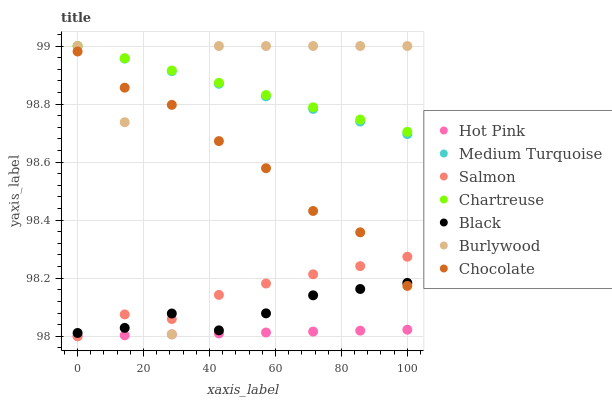Does Hot Pink have the minimum area under the curve?
Answer yes or no. Yes. Does Chartreuse have the maximum area under the curve?
Answer yes or no. Yes. Does Salmon have the minimum area under the curve?
Answer yes or no. No. Does Salmon have the maximum area under the curve?
Answer yes or no. No. Is Medium Turquoise the smoothest?
Answer yes or no. Yes. Is Burlywood the roughest?
Answer yes or no. Yes. Is Hot Pink the smoothest?
Answer yes or no. No. Is Hot Pink the roughest?
Answer yes or no. No. Does Hot Pink have the lowest value?
Answer yes or no. Yes. Does Chocolate have the lowest value?
Answer yes or no. No. Does Medium Turquoise have the highest value?
Answer yes or no. Yes. Does Salmon have the highest value?
Answer yes or no. No. Is Salmon less than Chartreuse?
Answer yes or no. Yes. Is Burlywood greater than Hot Pink?
Answer yes or no. Yes. Does Salmon intersect Black?
Answer yes or no. Yes. Is Salmon less than Black?
Answer yes or no. No. Is Salmon greater than Black?
Answer yes or no. No. Does Salmon intersect Chartreuse?
Answer yes or no. No. 